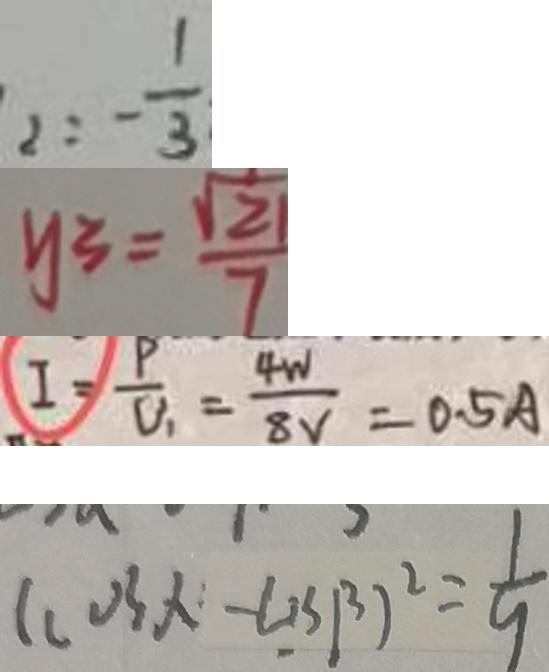Convert formula to latex. <formula><loc_0><loc_0><loc_500><loc_500>2 : - \frac { 1 } { 3 } 
 y _ { 3 } = \frac { \sqrt { 2 1 } } { 7 } 
 I = \frac { P } { V _ { 1 } } = \frac { 4 W } { 8 V } = 0 . 5 A 
 ( \cos x - \cos \beta ) ^ { 2 } = \frac { 1 } { 9 }</formula> 